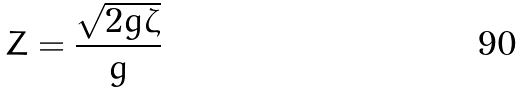<formula> <loc_0><loc_0><loc_500><loc_500>Z = \frac { \sqrt { 2 g \zeta } } { g }</formula> 